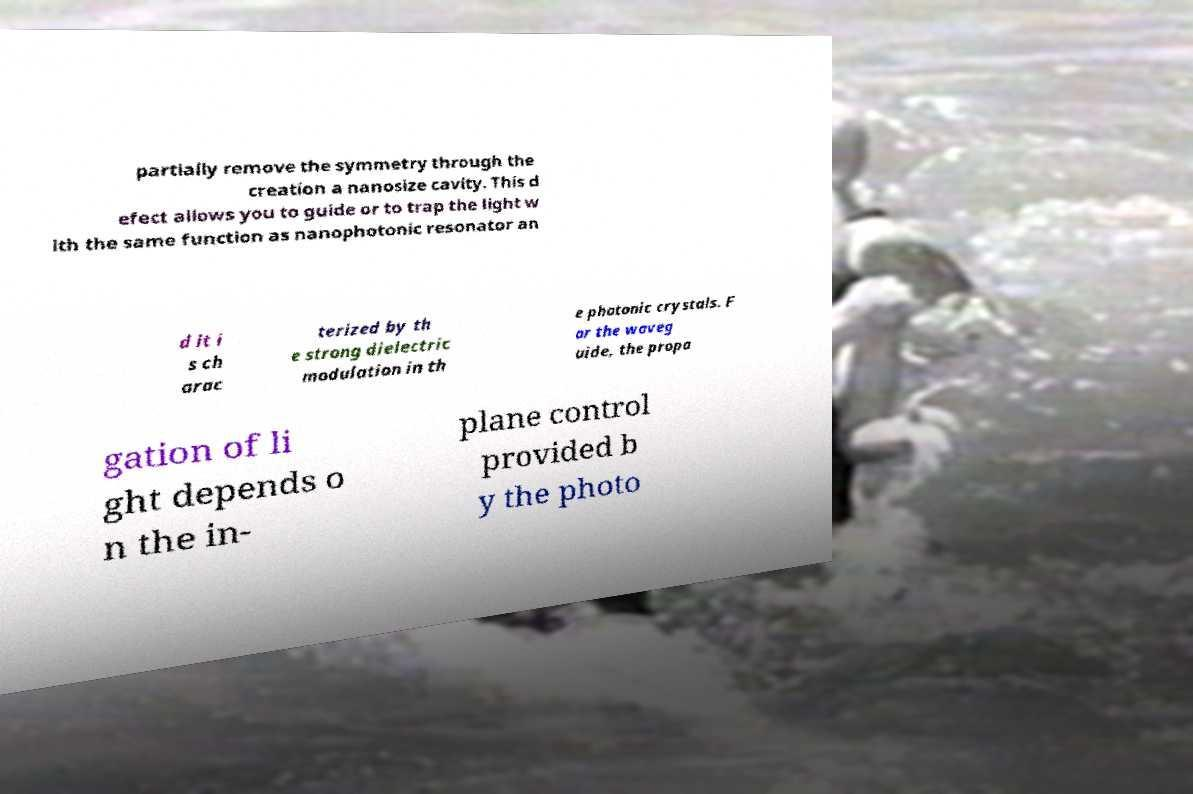What messages or text are displayed in this image? I need them in a readable, typed format. partially remove the symmetry through the creation a nanosize cavity. This d efect allows you to guide or to trap the light w ith the same function as nanophotonic resonator an d it i s ch arac terized by th e strong dielectric modulation in th e photonic crystals. F or the waveg uide, the propa gation of li ght depends o n the in- plane control provided b y the photo 